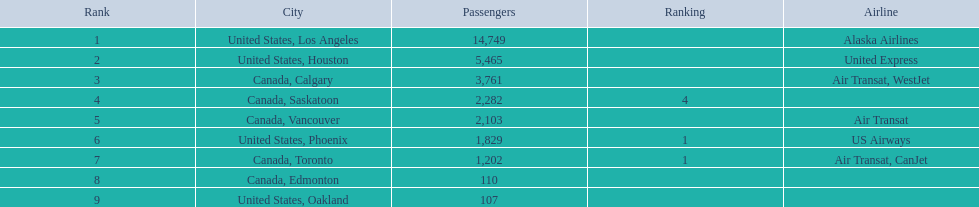Which airport has the least amount of passengers? 107. What airport has 107 passengers? United States, Oakland. 